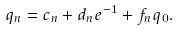Convert formula to latex. <formula><loc_0><loc_0><loc_500><loc_500>q _ { n } = c _ { n } + d _ { n } e ^ { - 1 } + f _ { n } q _ { 0 } .</formula> 